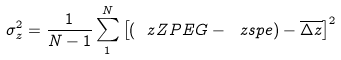<formula> <loc_0><loc_0><loc_500><loc_500>\sigma ^ { 2 } _ { z } = \frac { 1 } { N - 1 } \sum _ { 1 } ^ { N } \left [ ( \ z Z P E G - \ z s p e ) - \overline { \Delta z } \right ] ^ { 2 }</formula> 